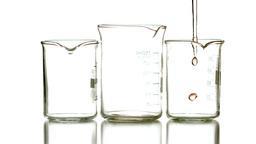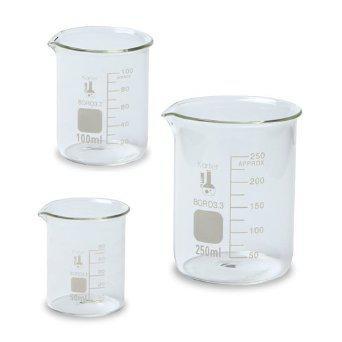The first image is the image on the left, the second image is the image on the right. For the images shown, is this caption "All of the measuring containers appear to be empty of liquid." true? Answer yes or no. No. The first image is the image on the left, the second image is the image on the right. For the images shown, is this caption "There are at most two beakers." true? Answer yes or no. No. 